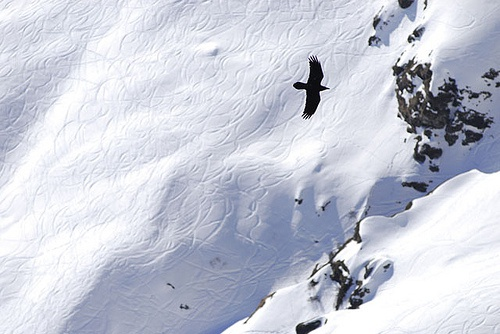Describe the objects in this image and their specific colors. I can see a bird in lavender, black, gray, and darkgray tones in this image. 